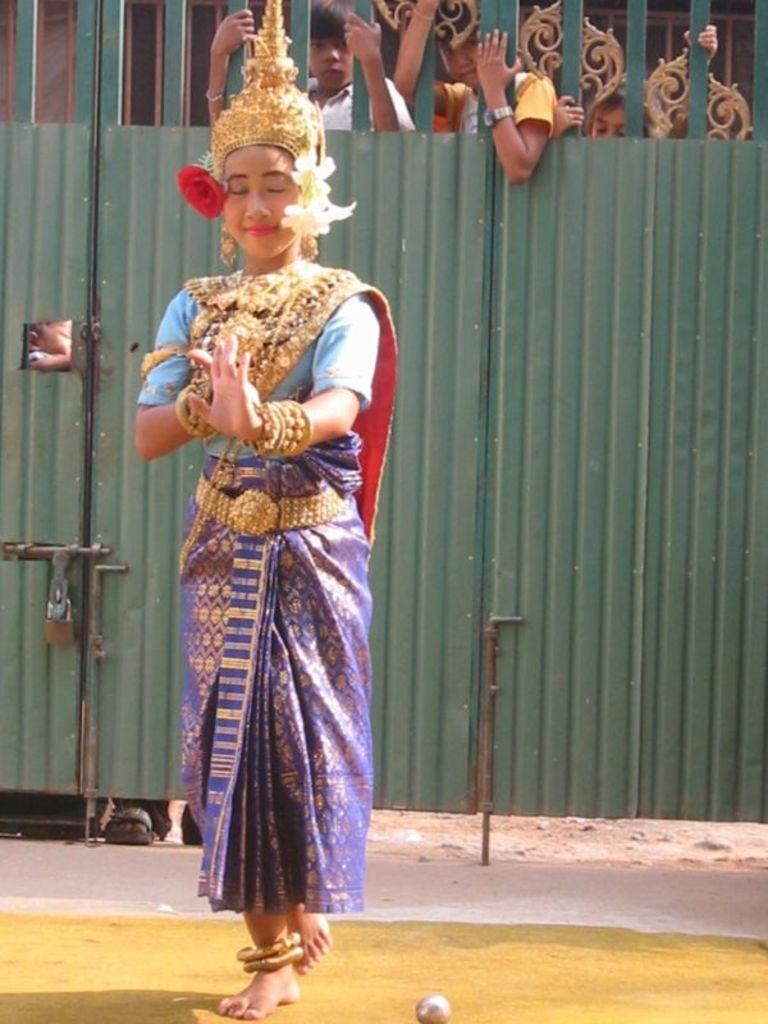Who is the main subject in the image? There is a woman in the image. What is the woman doing in the image? The woman is dancing on the ground. What is the woman wearing in the image? The woman is wearing a costume. What other objects can be seen in the image? There is a ball and a gate in the image. What is visible behind the gate in the image? There are people visible behind the gate. What type of powder is being used by the woman while dancing in the image? There is no powder visible in the image; the woman is simply dancing in a costume. 